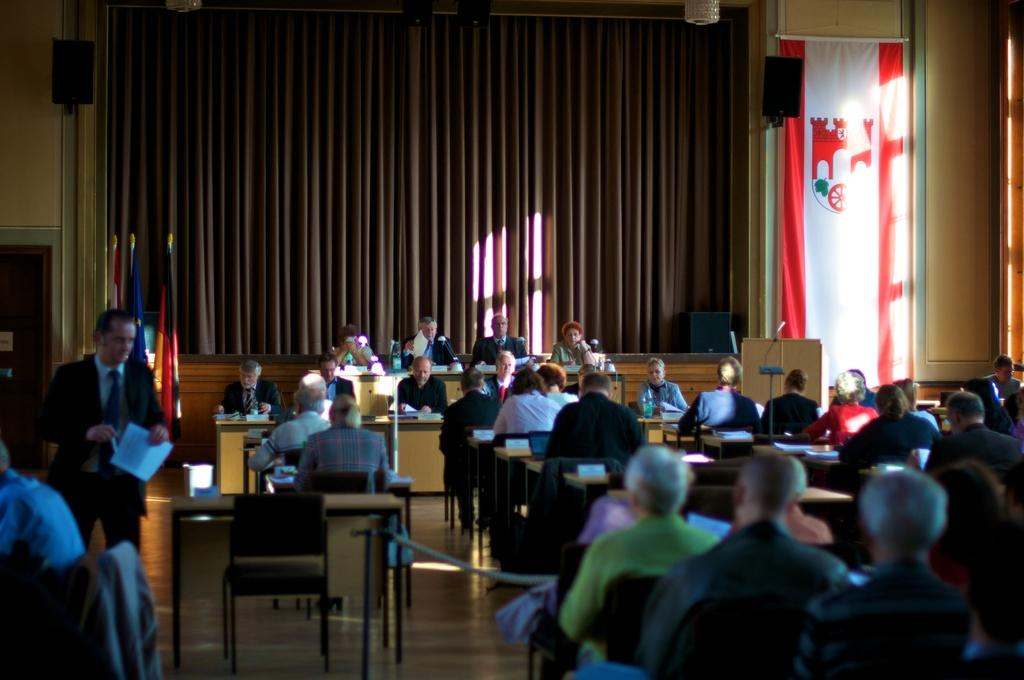How many people are in the image? There is a group of people in the image, but the exact number is not specified. What are the people doing in the image? Some of the people are sitting, while others are standing, and they are holding papers. What can be seen in the background of the image? There is a curtain in the background of the image. How much dirt is visible on the floor in the image? There is no dirt visible on the floor in the image. What shape does the circle take in the image? There is no circle present in the image. 